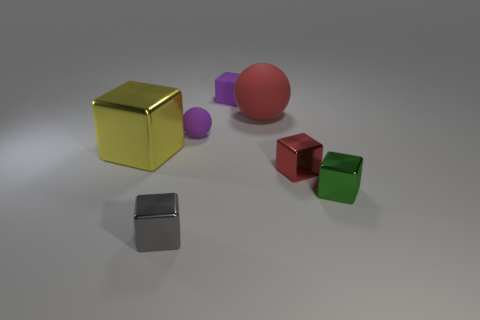There is a shiny cube that is the same color as the large matte object; what size is it?
Your response must be concise. Small. What material is the thing that is the same color as the small sphere?
Your answer should be very brief. Rubber. Is there a small metallic block that has the same color as the big rubber sphere?
Your answer should be very brief. Yes. Does the yellow object have the same shape as the green thing?
Your response must be concise. Yes. What number of other things are the same size as the red shiny thing?
Give a very brief answer. 4. How many objects are either metal objects to the left of the small purple block or cubes that are right of the tiny red metal object?
Your answer should be very brief. 3. What number of red shiny objects are the same shape as the large yellow metallic object?
Ensure brevity in your answer.  1. There is a tiny block that is right of the small purple cube and in front of the tiny red thing; what material is it made of?
Provide a succinct answer. Metal. There is a small green cube; what number of red matte spheres are in front of it?
Ensure brevity in your answer.  0. How many small gray rubber objects are there?
Provide a short and direct response. 0. 